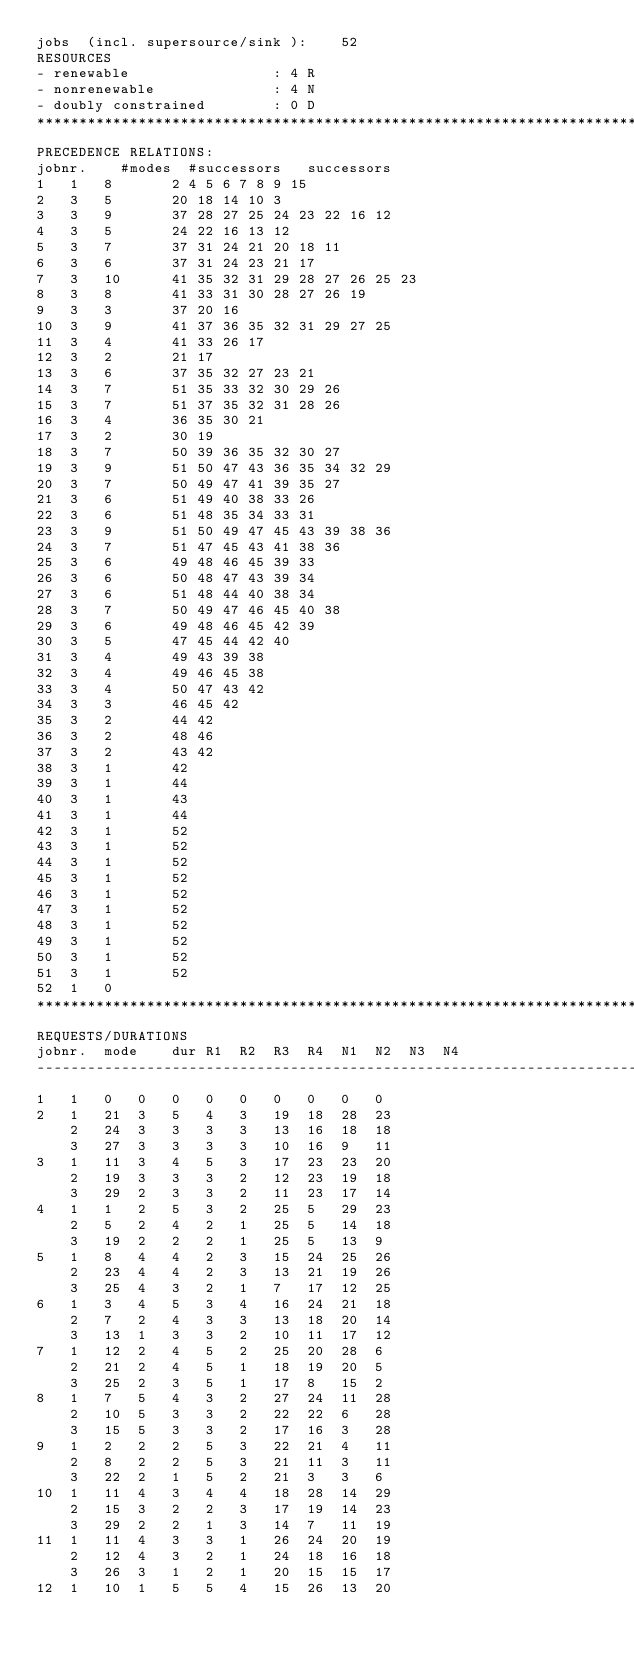Convert code to text. <code><loc_0><loc_0><loc_500><loc_500><_ObjectiveC_>jobs  (incl. supersource/sink ):	52
RESOURCES
- renewable                 : 4 R
- nonrenewable              : 4 N
- doubly constrained        : 0 D
************************************************************************
PRECEDENCE RELATIONS:
jobnr.    #modes  #successors   successors
1	1	8		2 4 5 6 7 8 9 15 
2	3	5		20 18 14 10 3 
3	3	9		37 28 27 25 24 23 22 16 12 
4	3	5		24 22 16 13 12 
5	3	7		37 31 24 21 20 18 11 
6	3	6		37 31 24 23 21 17 
7	3	10		41 35 32 31 29 28 27 26 25 23 
8	3	8		41 33 31 30 28 27 26 19 
9	3	3		37 20 16 
10	3	9		41 37 36 35 32 31 29 27 25 
11	3	4		41 33 26 17 
12	3	2		21 17 
13	3	6		37 35 32 27 23 21 
14	3	7		51 35 33 32 30 29 26 
15	3	7		51 37 35 32 31 28 26 
16	3	4		36 35 30 21 
17	3	2		30 19 
18	3	7		50 39 36 35 32 30 27 
19	3	9		51 50 47 43 36 35 34 32 29 
20	3	7		50 49 47 41 39 35 27 
21	3	6		51 49 40 38 33 26 
22	3	6		51 48 35 34 33 31 
23	3	9		51 50 49 47 45 43 39 38 36 
24	3	7		51 47 45 43 41 38 36 
25	3	6		49 48 46 45 39 33 
26	3	6		50 48 47 43 39 34 
27	3	6		51 48 44 40 38 34 
28	3	7		50 49 47 46 45 40 38 
29	3	6		49 48 46 45 42 39 
30	3	5		47 45 44 42 40 
31	3	4		49 43 39 38 
32	3	4		49 46 45 38 
33	3	4		50 47 43 42 
34	3	3		46 45 42 
35	3	2		44 42 
36	3	2		48 46 
37	3	2		43 42 
38	3	1		42 
39	3	1		44 
40	3	1		43 
41	3	1		44 
42	3	1		52 
43	3	1		52 
44	3	1		52 
45	3	1		52 
46	3	1		52 
47	3	1		52 
48	3	1		52 
49	3	1		52 
50	3	1		52 
51	3	1		52 
52	1	0		
************************************************************************
REQUESTS/DURATIONS
jobnr.	mode	dur	R1	R2	R3	R4	N1	N2	N3	N4	
------------------------------------------------------------------------
1	1	0	0	0	0	0	0	0	0	0	
2	1	21	3	5	4	3	19	18	28	23	
	2	24	3	3	3	3	13	16	18	18	
	3	27	3	3	3	3	10	16	9	11	
3	1	11	3	4	5	3	17	23	23	20	
	2	19	3	3	3	2	12	23	19	18	
	3	29	2	3	3	2	11	23	17	14	
4	1	1	2	5	3	2	25	5	29	23	
	2	5	2	4	2	1	25	5	14	18	
	3	19	2	2	2	1	25	5	13	9	
5	1	8	4	4	2	3	15	24	25	26	
	2	23	4	4	2	3	13	21	19	26	
	3	25	4	3	2	1	7	17	12	25	
6	1	3	4	5	3	4	16	24	21	18	
	2	7	2	4	3	3	13	18	20	14	
	3	13	1	3	3	2	10	11	17	12	
7	1	12	2	4	5	2	25	20	28	6	
	2	21	2	4	5	1	18	19	20	5	
	3	25	2	3	5	1	17	8	15	2	
8	1	7	5	4	3	2	27	24	11	28	
	2	10	5	3	3	2	22	22	6	28	
	3	15	5	3	3	2	17	16	3	28	
9	1	2	2	2	5	3	22	21	4	11	
	2	8	2	2	5	3	21	11	3	11	
	3	22	2	1	5	2	21	3	3	6	
10	1	11	4	3	4	4	18	28	14	29	
	2	15	3	2	2	3	17	19	14	23	
	3	29	2	2	1	3	14	7	11	19	
11	1	11	4	3	3	1	26	24	20	19	
	2	12	4	3	2	1	24	18	16	18	
	3	26	3	1	2	1	20	15	15	17	
12	1	10	1	5	5	4	15	26	13	20	</code> 